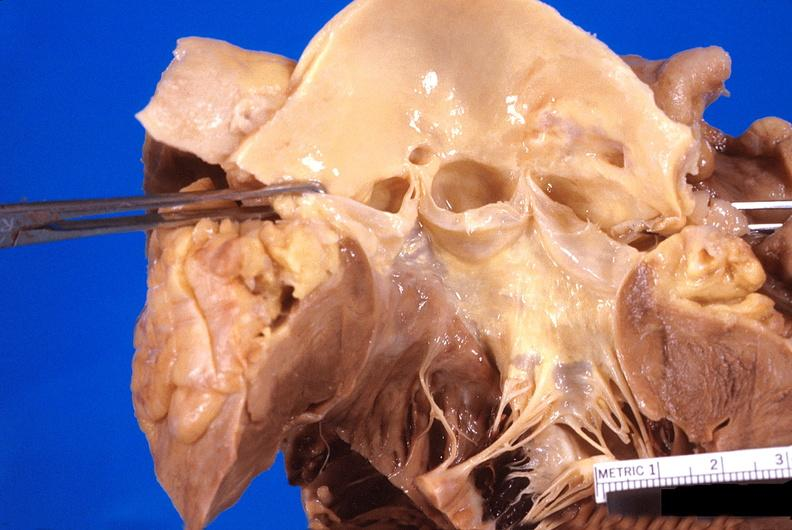what does this image show?
Answer the question using a single word or phrase. Abnormal location of coronary artery ostia 